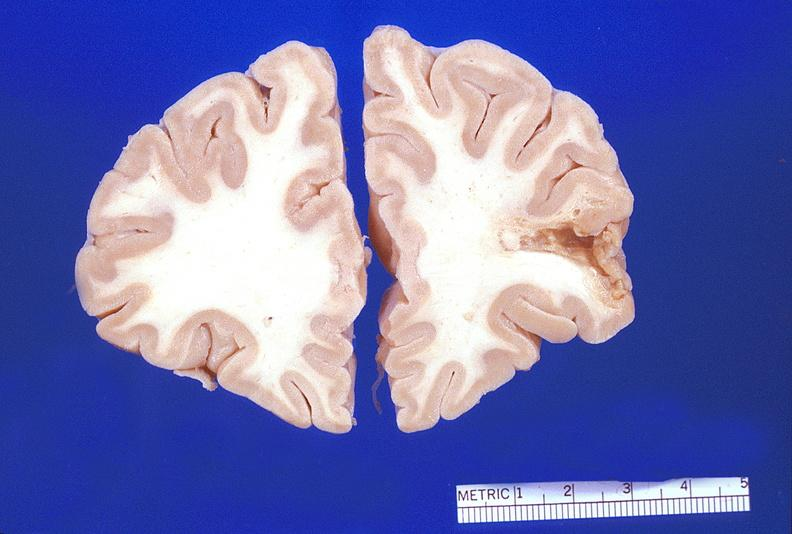what is present?
Answer the question using a single word or phrase. Nervous 